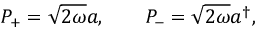Convert formula to latex. <formula><loc_0><loc_0><loc_500><loc_500>P _ { + } = \sqrt { 2 \omega } a , \quad P _ { - } = \sqrt { 2 \omega } a ^ { \dagger } ,</formula> 